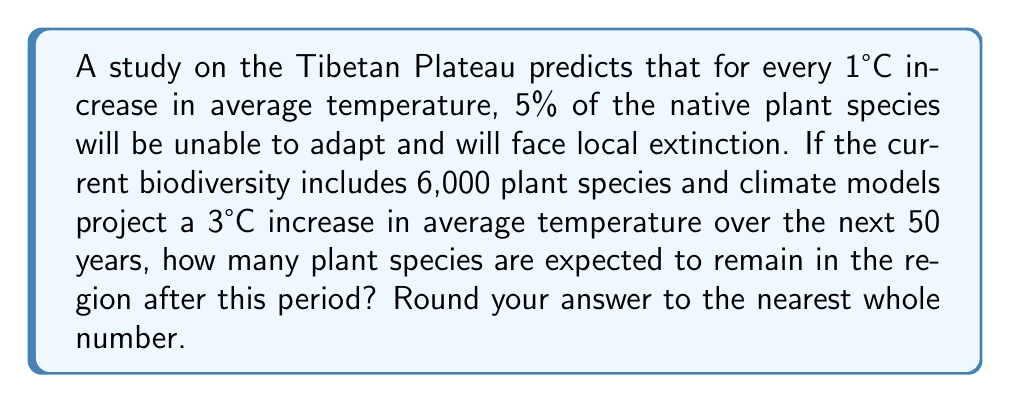Can you solve this math problem? To solve this problem, we need to follow these steps:

1. Calculate the percentage of species that will remain after the temperature increase:
   - For each 1°C increase, 5% of species are lost
   - The temperature is projected to increase by 3°C
   - Total percentage lost = 3 × 5% = 15%
   - Percentage remaining = 100% - 15% = 85% or 0.85

2. Calculate the number of species remaining:
   - Current number of species = 6,000
   - Number of species remaining = Current species × Percentage remaining
   
Let's express this mathematically:

$$S_r = S_c \times (1 - r \times T)$$

Where:
$S_r$ = Number of species remaining
$S_c$ = Current number of species
$r$ = Rate of species loss per °C (as a decimal)
$T$ = Projected temperature increase in °C

Plugging in our values:

$$S_r = 6000 \times (1 - 0.05 \times 3)$$
$$S_r = 6000 \times (1 - 0.15)$$
$$S_r = 6000 \times 0.85$$
$$S_r = 5100$$

Rounding to the nearest whole number, we get 5,100 species.
Answer: 5,100 plant species 